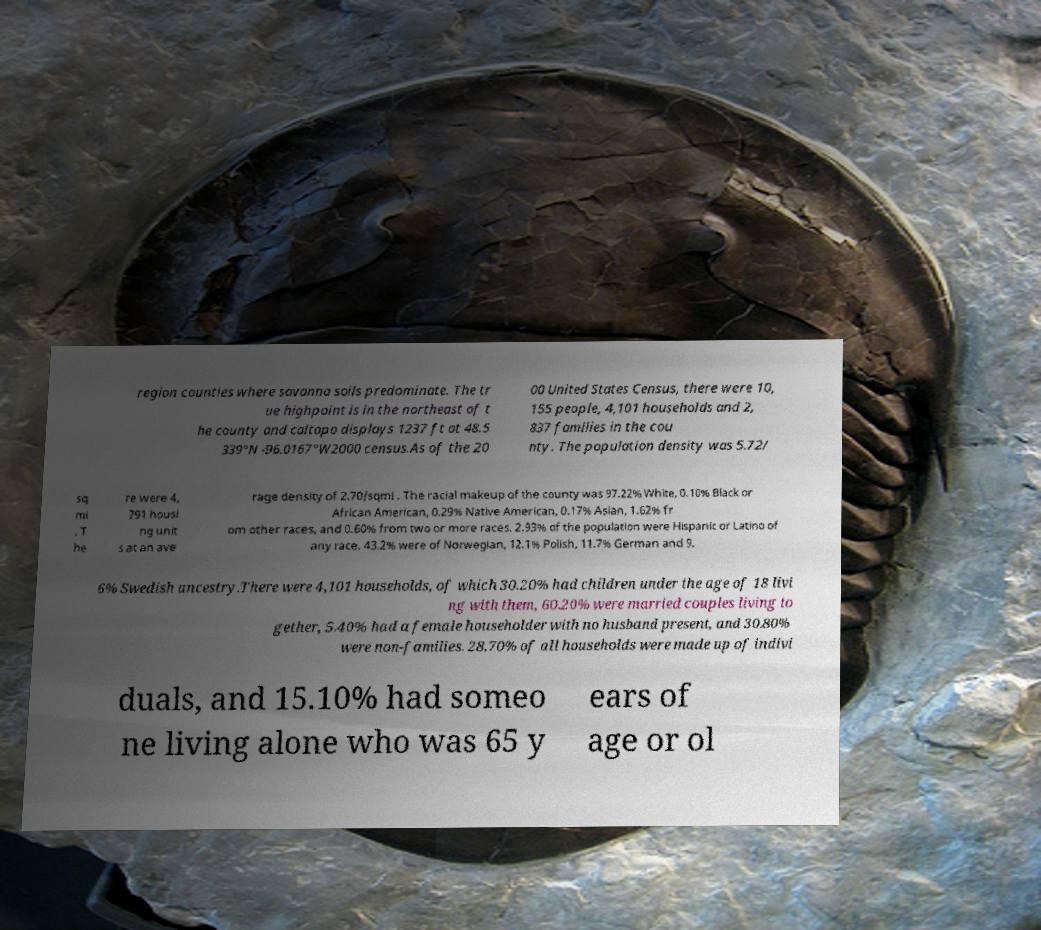Could you extract and type out the text from this image? region counties where savanna soils predominate. The tr ue highpoint is in the northeast of t he county and caltopo displays 1237 ft at 48.5 339°N -96.0167°W2000 census.As of the 20 00 United States Census, there were 10, 155 people, 4,101 households and 2, 837 families in the cou nty. The population density was 5.72/ sq mi . T he re were 4, 791 housi ng unit s at an ave rage density of 2.70/sqmi . The racial makeup of the county was 97.22% White, 0.10% Black or African American, 0.29% Native American, 0.17% Asian, 1.62% fr om other races, and 0.60% from two or more races. 2.93% of the population were Hispanic or Latino of any race. 43.2% were of Norwegian, 12.1% Polish, 11.7% German and 9. 6% Swedish ancestry.There were 4,101 households, of which 30.20% had children under the age of 18 livi ng with them, 60.20% were married couples living to gether, 5.40% had a female householder with no husband present, and 30.80% were non-families. 28.70% of all households were made up of indivi duals, and 15.10% had someo ne living alone who was 65 y ears of age or ol 